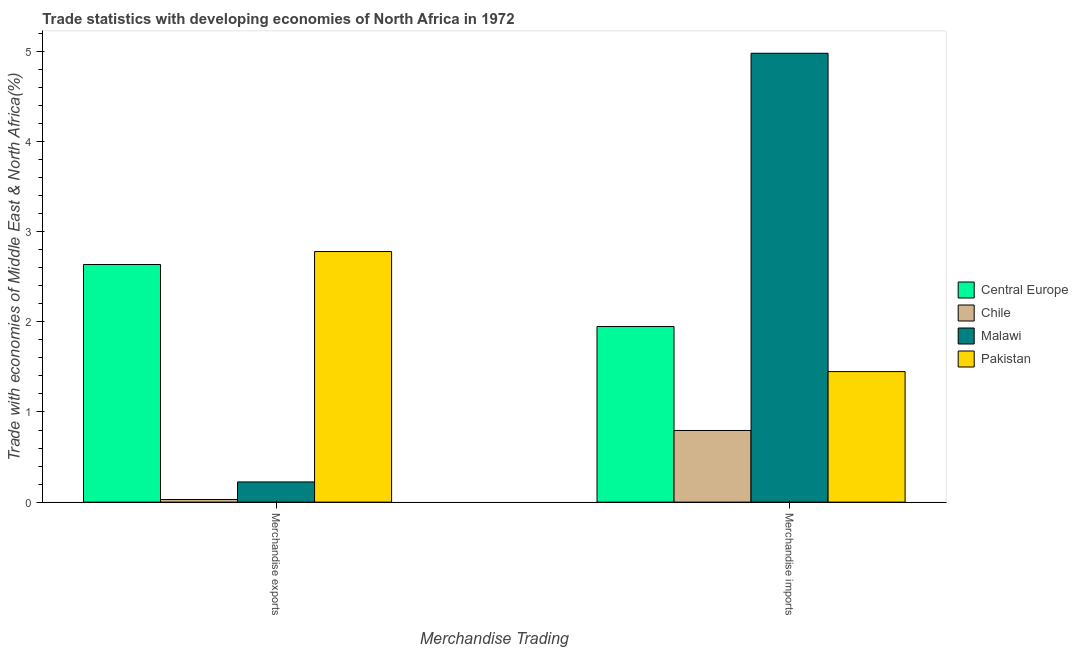How many different coloured bars are there?
Offer a very short reply. 4. How many groups of bars are there?
Offer a very short reply. 2. Are the number of bars per tick equal to the number of legend labels?
Make the answer very short. Yes. What is the label of the 2nd group of bars from the left?
Your answer should be very brief. Merchandise imports. What is the merchandise imports in Central Europe?
Your answer should be very brief. 1.95. Across all countries, what is the maximum merchandise imports?
Offer a very short reply. 4.98. Across all countries, what is the minimum merchandise imports?
Provide a succinct answer. 0.79. In which country was the merchandise imports maximum?
Offer a very short reply. Malawi. In which country was the merchandise imports minimum?
Your response must be concise. Chile. What is the total merchandise imports in the graph?
Your response must be concise. 9.17. What is the difference between the merchandise imports in Central Europe and that in Chile?
Provide a short and direct response. 1.15. What is the difference between the merchandise imports in Central Europe and the merchandise exports in Chile?
Give a very brief answer. 1.92. What is the average merchandise exports per country?
Offer a terse response. 1.42. What is the difference between the merchandise exports and merchandise imports in Central Europe?
Give a very brief answer. 0.69. In how many countries, is the merchandise exports greater than 1.6 %?
Give a very brief answer. 2. What is the ratio of the merchandise exports in Pakistan to that in Central Europe?
Offer a terse response. 1.05. What does the 1st bar from the left in Merchandise imports represents?
Provide a succinct answer. Central Europe. How many bars are there?
Offer a very short reply. 8. How many countries are there in the graph?
Make the answer very short. 4. Where does the legend appear in the graph?
Offer a very short reply. Center right. How many legend labels are there?
Offer a very short reply. 4. What is the title of the graph?
Make the answer very short. Trade statistics with developing economies of North Africa in 1972. What is the label or title of the X-axis?
Provide a short and direct response. Merchandise Trading. What is the label or title of the Y-axis?
Offer a terse response. Trade with economies of Middle East & North Africa(%). What is the Trade with economies of Middle East & North Africa(%) in Central Europe in Merchandise exports?
Make the answer very short. 2.64. What is the Trade with economies of Middle East & North Africa(%) in Chile in Merchandise exports?
Provide a short and direct response. 0.03. What is the Trade with economies of Middle East & North Africa(%) of Malawi in Merchandise exports?
Keep it short and to the point. 0.22. What is the Trade with economies of Middle East & North Africa(%) of Pakistan in Merchandise exports?
Offer a terse response. 2.78. What is the Trade with economies of Middle East & North Africa(%) of Central Europe in Merchandise imports?
Give a very brief answer. 1.95. What is the Trade with economies of Middle East & North Africa(%) of Chile in Merchandise imports?
Offer a very short reply. 0.79. What is the Trade with economies of Middle East & North Africa(%) of Malawi in Merchandise imports?
Your answer should be very brief. 4.98. What is the Trade with economies of Middle East & North Africa(%) in Pakistan in Merchandise imports?
Keep it short and to the point. 1.45. Across all Merchandise Trading, what is the maximum Trade with economies of Middle East & North Africa(%) in Central Europe?
Provide a short and direct response. 2.64. Across all Merchandise Trading, what is the maximum Trade with economies of Middle East & North Africa(%) in Chile?
Provide a short and direct response. 0.79. Across all Merchandise Trading, what is the maximum Trade with economies of Middle East & North Africa(%) of Malawi?
Your response must be concise. 4.98. Across all Merchandise Trading, what is the maximum Trade with economies of Middle East & North Africa(%) of Pakistan?
Give a very brief answer. 2.78. Across all Merchandise Trading, what is the minimum Trade with economies of Middle East & North Africa(%) in Central Europe?
Your response must be concise. 1.95. Across all Merchandise Trading, what is the minimum Trade with economies of Middle East & North Africa(%) in Chile?
Make the answer very short. 0.03. Across all Merchandise Trading, what is the minimum Trade with economies of Middle East & North Africa(%) in Malawi?
Offer a terse response. 0.22. Across all Merchandise Trading, what is the minimum Trade with economies of Middle East & North Africa(%) in Pakistan?
Your response must be concise. 1.45. What is the total Trade with economies of Middle East & North Africa(%) in Central Europe in the graph?
Offer a terse response. 4.58. What is the total Trade with economies of Middle East & North Africa(%) of Chile in the graph?
Provide a succinct answer. 0.82. What is the total Trade with economies of Middle East & North Africa(%) of Malawi in the graph?
Your answer should be compact. 5.2. What is the total Trade with economies of Middle East & North Africa(%) in Pakistan in the graph?
Provide a short and direct response. 4.23. What is the difference between the Trade with economies of Middle East & North Africa(%) of Central Europe in Merchandise exports and that in Merchandise imports?
Your response must be concise. 0.69. What is the difference between the Trade with economies of Middle East & North Africa(%) in Chile in Merchandise exports and that in Merchandise imports?
Your response must be concise. -0.77. What is the difference between the Trade with economies of Middle East & North Africa(%) of Malawi in Merchandise exports and that in Merchandise imports?
Keep it short and to the point. -4.76. What is the difference between the Trade with economies of Middle East & North Africa(%) in Pakistan in Merchandise exports and that in Merchandise imports?
Offer a terse response. 1.33. What is the difference between the Trade with economies of Middle East & North Africa(%) of Central Europe in Merchandise exports and the Trade with economies of Middle East & North Africa(%) of Chile in Merchandise imports?
Provide a short and direct response. 1.84. What is the difference between the Trade with economies of Middle East & North Africa(%) of Central Europe in Merchandise exports and the Trade with economies of Middle East & North Africa(%) of Malawi in Merchandise imports?
Your answer should be compact. -2.34. What is the difference between the Trade with economies of Middle East & North Africa(%) of Central Europe in Merchandise exports and the Trade with economies of Middle East & North Africa(%) of Pakistan in Merchandise imports?
Offer a terse response. 1.19. What is the difference between the Trade with economies of Middle East & North Africa(%) of Chile in Merchandise exports and the Trade with economies of Middle East & North Africa(%) of Malawi in Merchandise imports?
Your answer should be very brief. -4.95. What is the difference between the Trade with economies of Middle East & North Africa(%) in Chile in Merchandise exports and the Trade with economies of Middle East & North Africa(%) in Pakistan in Merchandise imports?
Provide a short and direct response. -1.42. What is the difference between the Trade with economies of Middle East & North Africa(%) in Malawi in Merchandise exports and the Trade with economies of Middle East & North Africa(%) in Pakistan in Merchandise imports?
Offer a terse response. -1.22. What is the average Trade with economies of Middle East & North Africa(%) in Central Europe per Merchandise Trading?
Keep it short and to the point. 2.29. What is the average Trade with economies of Middle East & North Africa(%) in Chile per Merchandise Trading?
Your answer should be compact. 0.41. What is the average Trade with economies of Middle East & North Africa(%) in Malawi per Merchandise Trading?
Provide a short and direct response. 2.6. What is the average Trade with economies of Middle East & North Africa(%) in Pakistan per Merchandise Trading?
Your answer should be compact. 2.11. What is the difference between the Trade with economies of Middle East & North Africa(%) in Central Europe and Trade with economies of Middle East & North Africa(%) in Chile in Merchandise exports?
Offer a terse response. 2.61. What is the difference between the Trade with economies of Middle East & North Africa(%) in Central Europe and Trade with economies of Middle East & North Africa(%) in Malawi in Merchandise exports?
Make the answer very short. 2.41. What is the difference between the Trade with economies of Middle East & North Africa(%) in Central Europe and Trade with economies of Middle East & North Africa(%) in Pakistan in Merchandise exports?
Your answer should be very brief. -0.14. What is the difference between the Trade with economies of Middle East & North Africa(%) of Chile and Trade with economies of Middle East & North Africa(%) of Malawi in Merchandise exports?
Keep it short and to the point. -0.19. What is the difference between the Trade with economies of Middle East & North Africa(%) in Chile and Trade with economies of Middle East & North Africa(%) in Pakistan in Merchandise exports?
Offer a very short reply. -2.75. What is the difference between the Trade with economies of Middle East & North Africa(%) in Malawi and Trade with economies of Middle East & North Africa(%) in Pakistan in Merchandise exports?
Give a very brief answer. -2.56. What is the difference between the Trade with economies of Middle East & North Africa(%) of Central Europe and Trade with economies of Middle East & North Africa(%) of Chile in Merchandise imports?
Ensure brevity in your answer.  1.15. What is the difference between the Trade with economies of Middle East & North Africa(%) of Central Europe and Trade with economies of Middle East & North Africa(%) of Malawi in Merchandise imports?
Provide a short and direct response. -3.03. What is the difference between the Trade with economies of Middle East & North Africa(%) of Central Europe and Trade with economies of Middle East & North Africa(%) of Pakistan in Merchandise imports?
Offer a very short reply. 0.5. What is the difference between the Trade with economies of Middle East & North Africa(%) in Chile and Trade with economies of Middle East & North Africa(%) in Malawi in Merchandise imports?
Your answer should be compact. -4.18. What is the difference between the Trade with economies of Middle East & North Africa(%) in Chile and Trade with economies of Middle East & North Africa(%) in Pakistan in Merchandise imports?
Provide a succinct answer. -0.65. What is the difference between the Trade with economies of Middle East & North Africa(%) of Malawi and Trade with economies of Middle East & North Africa(%) of Pakistan in Merchandise imports?
Ensure brevity in your answer.  3.53. What is the ratio of the Trade with economies of Middle East & North Africa(%) in Central Europe in Merchandise exports to that in Merchandise imports?
Your response must be concise. 1.35. What is the ratio of the Trade with economies of Middle East & North Africa(%) of Chile in Merchandise exports to that in Merchandise imports?
Offer a terse response. 0.04. What is the ratio of the Trade with economies of Middle East & North Africa(%) in Malawi in Merchandise exports to that in Merchandise imports?
Provide a short and direct response. 0.04. What is the ratio of the Trade with economies of Middle East & North Africa(%) in Pakistan in Merchandise exports to that in Merchandise imports?
Keep it short and to the point. 1.92. What is the difference between the highest and the second highest Trade with economies of Middle East & North Africa(%) of Central Europe?
Provide a short and direct response. 0.69. What is the difference between the highest and the second highest Trade with economies of Middle East & North Africa(%) of Chile?
Provide a succinct answer. 0.77. What is the difference between the highest and the second highest Trade with economies of Middle East & North Africa(%) of Malawi?
Your answer should be very brief. 4.76. What is the difference between the highest and the second highest Trade with economies of Middle East & North Africa(%) in Pakistan?
Make the answer very short. 1.33. What is the difference between the highest and the lowest Trade with economies of Middle East & North Africa(%) of Central Europe?
Give a very brief answer. 0.69. What is the difference between the highest and the lowest Trade with economies of Middle East & North Africa(%) of Chile?
Your response must be concise. 0.77. What is the difference between the highest and the lowest Trade with economies of Middle East & North Africa(%) in Malawi?
Offer a very short reply. 4.76. What is the difference between the highest and the lowest Trade with economies of Middle East & North Africa(%) in Pakistan?
Make the answer very short. 1.33. 